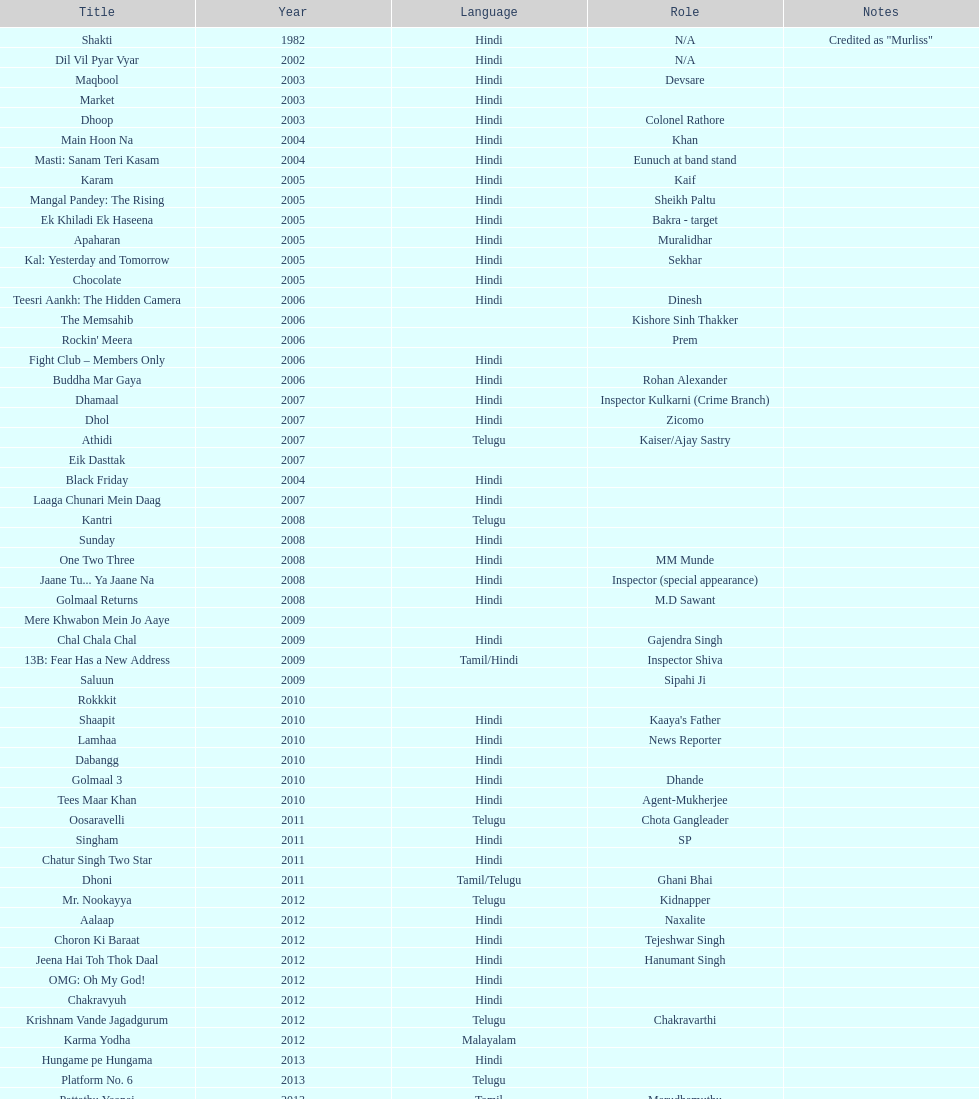What are the number of titles listed in 2005? 6. 